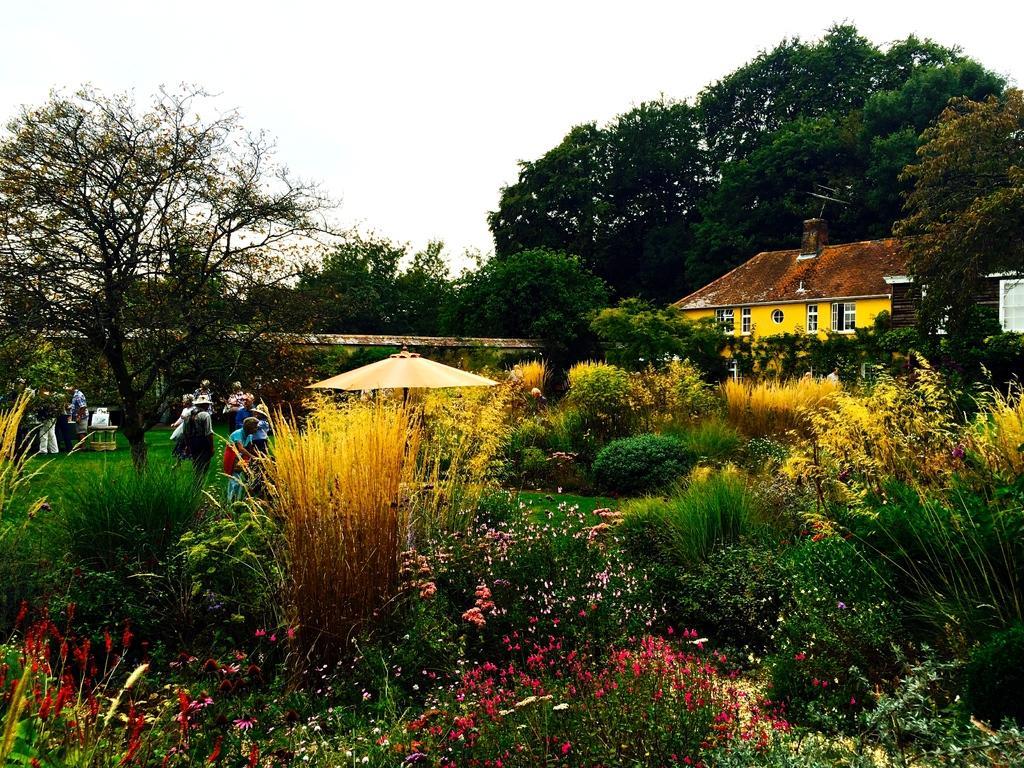Could you give a brief overview of what you see in this image? In this picture there are buildings and trees. On the left side of the image there are group of people. In the foreground there is an umbrella and there are flowers and plants. At the top there is sky. At the bottom there is grass. 